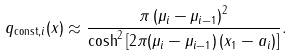<formula> <loc_0><loc_0><loc_500><loc_500>q _ { \text {const} , i } ( x ) \approx \frac { \pi \left ( \mu _ { i } - \mu _ { i - 1 } \right ) ^ { 2 } } { \cosh ^ { 2 } \left [ 2 \pi ( \mu _ { i } - \mu _ { i - 1 } ) \left ( x _ { 1 } - a _ { i } \right ) \right ] } .</formula> 